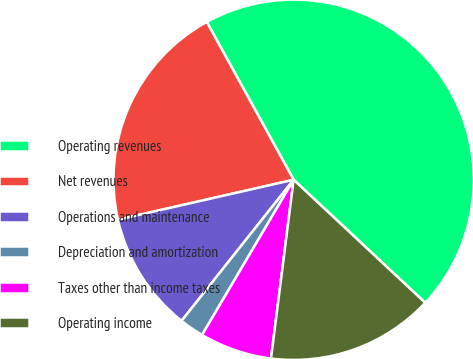Convert chart. <chart><loc_0><loc_0><loc_500><loc_500><pie_chart><fcel>Operating revenues<fcel>Net revenues<fcel>Operations and maintenance<fcel>Depreciation and amortization<fcel>Taxes other than income taxes<fcel>Operating income<nl><fcel>44.98%<fcel>20.55%<fcel>10.76%<fcel>2.2%<fcel>6.48%<fcel>15.04%<nl></chart> 